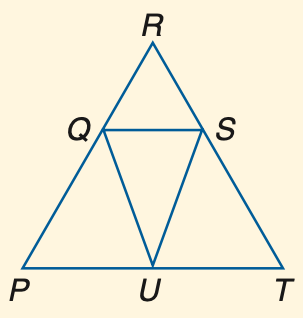Answer the mathemtical geometry problem and directly provide the correct option letter.
Question: If P Q \cong U Q and m \angle P = 32, find m \angle P U Q.
Choices: A: 32 B: 74 C: 79 D: 116 A 